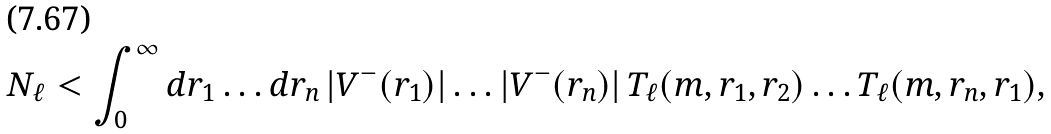Convert formula to latex. <formula><loc_0><loc_0><loc_500><loc_500>N _ { \ell } < \int _ { 0 } ^ { \infty } d r _ { 1 } \dots d r _ { n } \, | V ^ { - } ( r _ { 1 } ) | \dots | V ^ { - } ( r _ { n } ) | \, T _ { \ell } ( m , r _ { 1 } , r _ { 2 } ) \dots T _ { \ell } ( m , r _ { n } , r _ { 1 } ) ,</formula> 